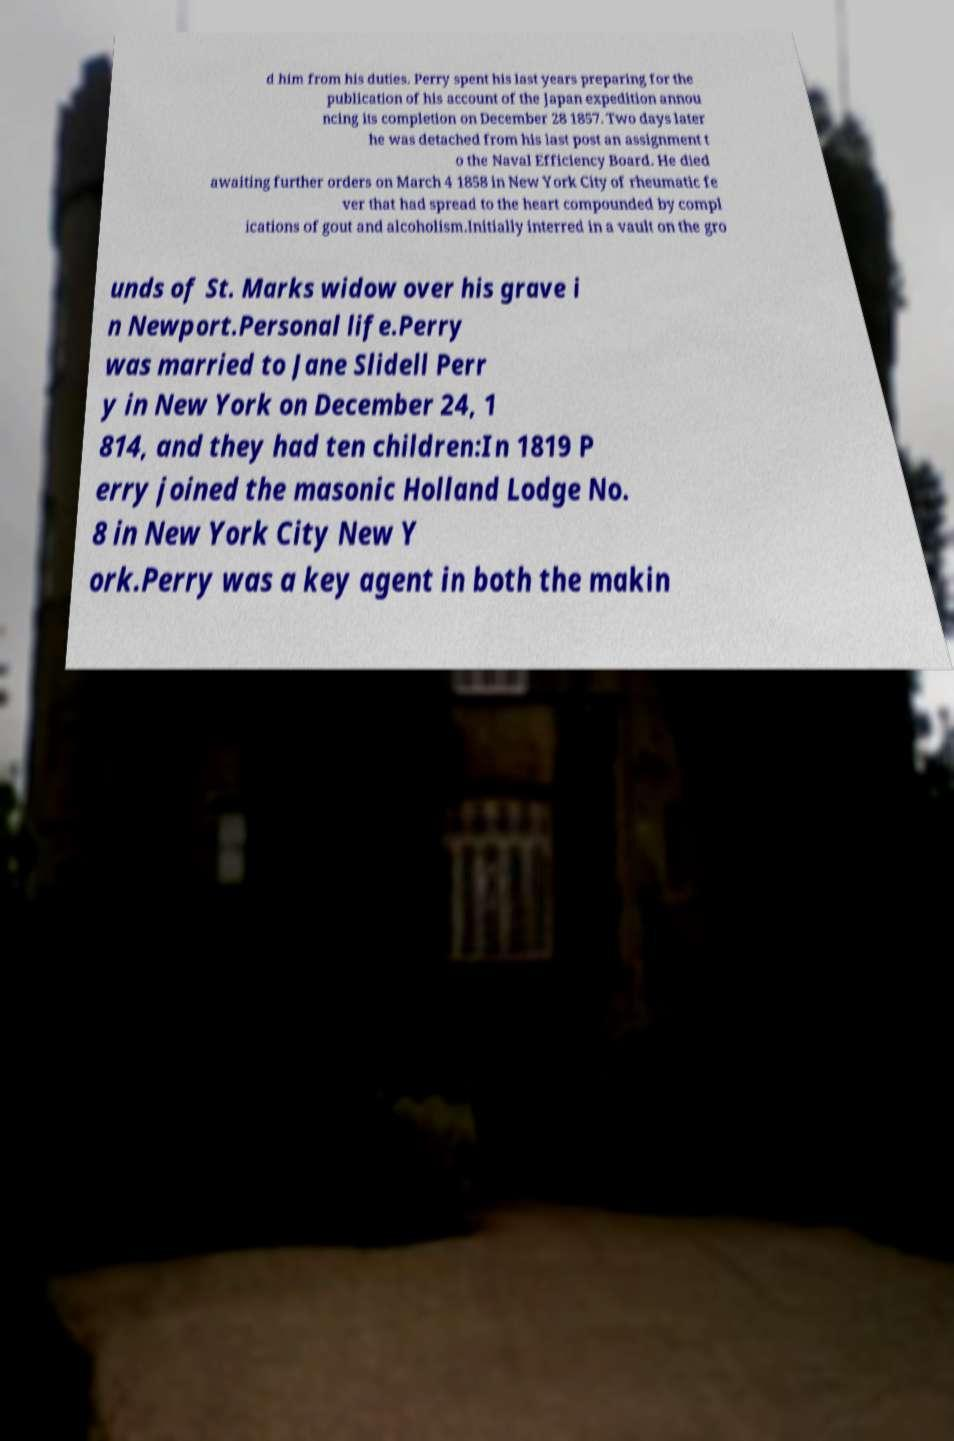Please read and relay the text visible in this image. What does it say? d him from his duties. Perry spent his last years preparing for the publication of his account of the Japan expedition annou ncing its completion on December 28 1857. Two days later he was detached from his last post an assignment t o the Naval Efficiency Board. He died awaiting further orders on March 4 1858 in New York City of rheumatic fe ver that had spread to the heart compounded by compl ications of gout and alcoholism.Initially interred in a vault on the gro unds of St. Marks widow over his grave i n Newport.Personal life.Perry was married to Jane Slidell Perr y in New York on December 24, 1 814, and they had ten children:In 1819 P erry joined the masonic Holland Lodge No. 8 in New York City New Y ork.Perry was a key agent in both the makin 